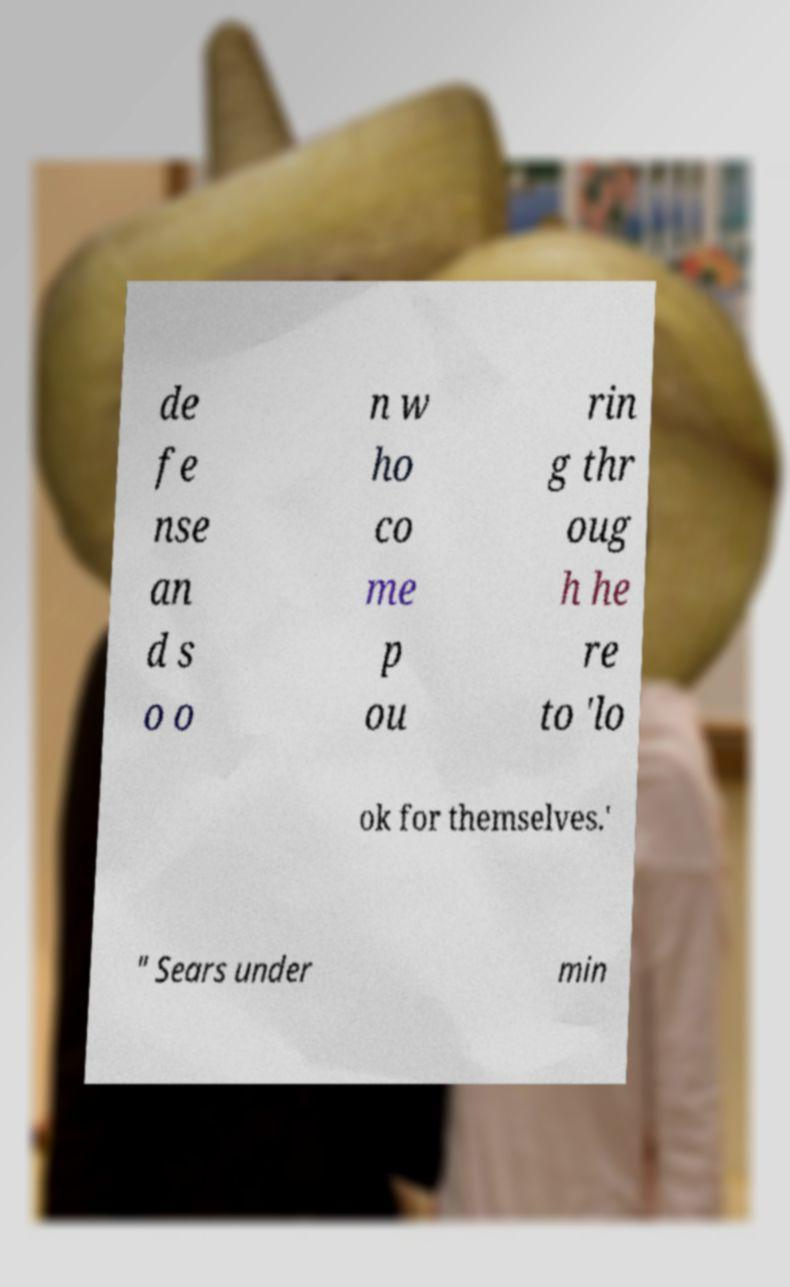There's text embedded in this image that I need extracted. Can you transcribe it verbatim? de fe nse an d s o o n w ho co me p ou rin g thr oug h he re to 'lo ok for themselves.' " Sears under min 